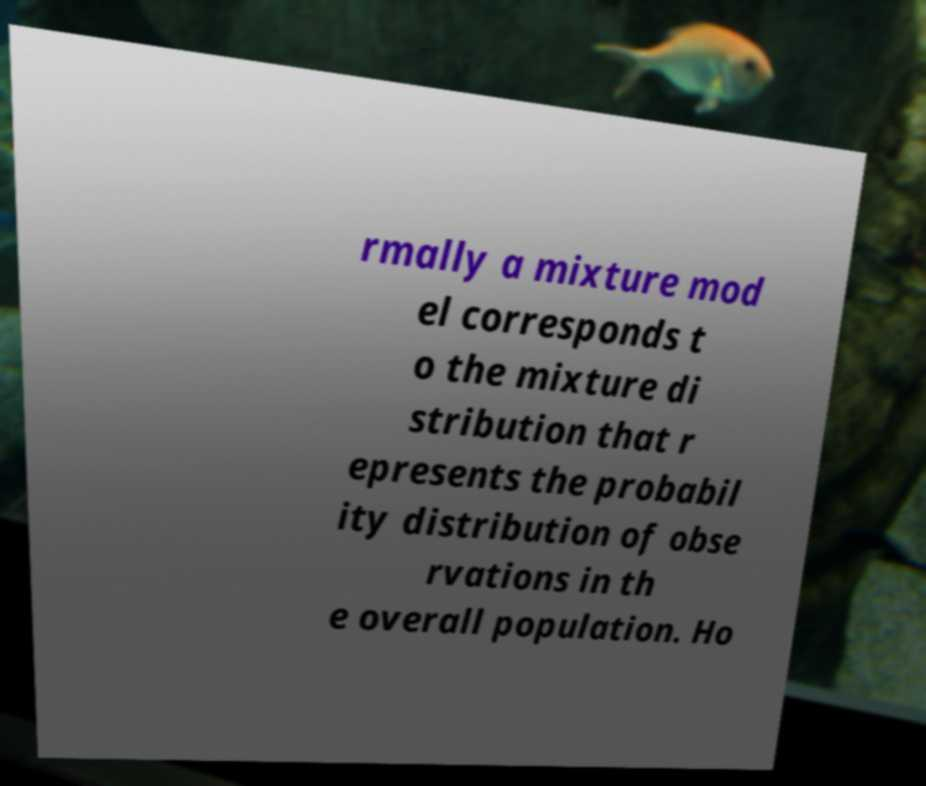Can you read and provide the text displayed in the image?This photo seems to have some interesting text. Can you extract and type it out for me? rmally a mixture mod el corresponds t o the mixture di stribution that r epresents the probabil ity distribution of obse rvations in th e overall population. Ho 